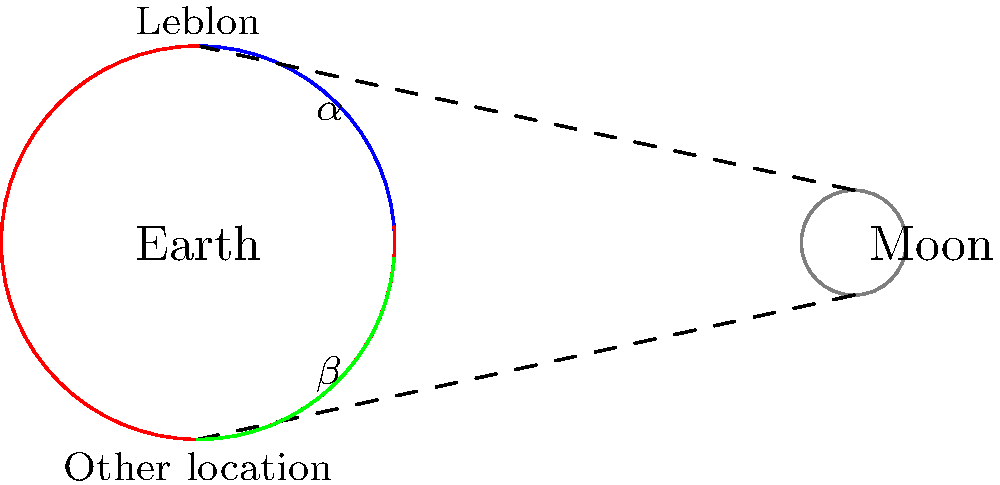As a resident of Leblon, you've often admired the Moon from Praia do Leblon. How does the apparent size of the Moon as seen from Leblon compare to its appearance from other locations on Earth, such as Sydney, Australia? To understand the apparent size of the Moon from different locations on Earth, we need to consider the following steps:

1. The Moon's distance from Earth: The average distance between the Earth and the Moon is approximately 384,400 km.

2. Earth's radius: The Earth's radius is about 6,371 km.

3. Comparison of distances:
   - Distance from Earth's center to the Moon: 384,400 km
   - Earth's radius: 6,371 km

4. Calculation of the difference:
   $384,400 - 6,371 = 378,029$ km

5. Percentage difference:
   $(6,371 / 378,029) \times 100 \approx 1.68\%$

6. Angular size: The angular size of the Moon is determined by the angle it subtends in our field of view. This angle is essentially the same whether viewed from Leblon or any other location on Earth's surface.

7. Visible difference: The 1.68% difference in distance is negligible in terms of the Moon's apparent size to the naked eye.

8. Factors affecting perception: Atmospheric conditions, the Moon's position in the sky, and psychological factors (like the Moon illusion) can make the Moon appear larger or smaller, but these are not related to the viewer's location on Earth.

Therefore, the apparent size of the Moon as seen from Leblon is virtually identical to its appearance from other locations on Earth, including Sydney, Australia.
Answer: The apparent size is the same from Leblon and other Earth locations. 